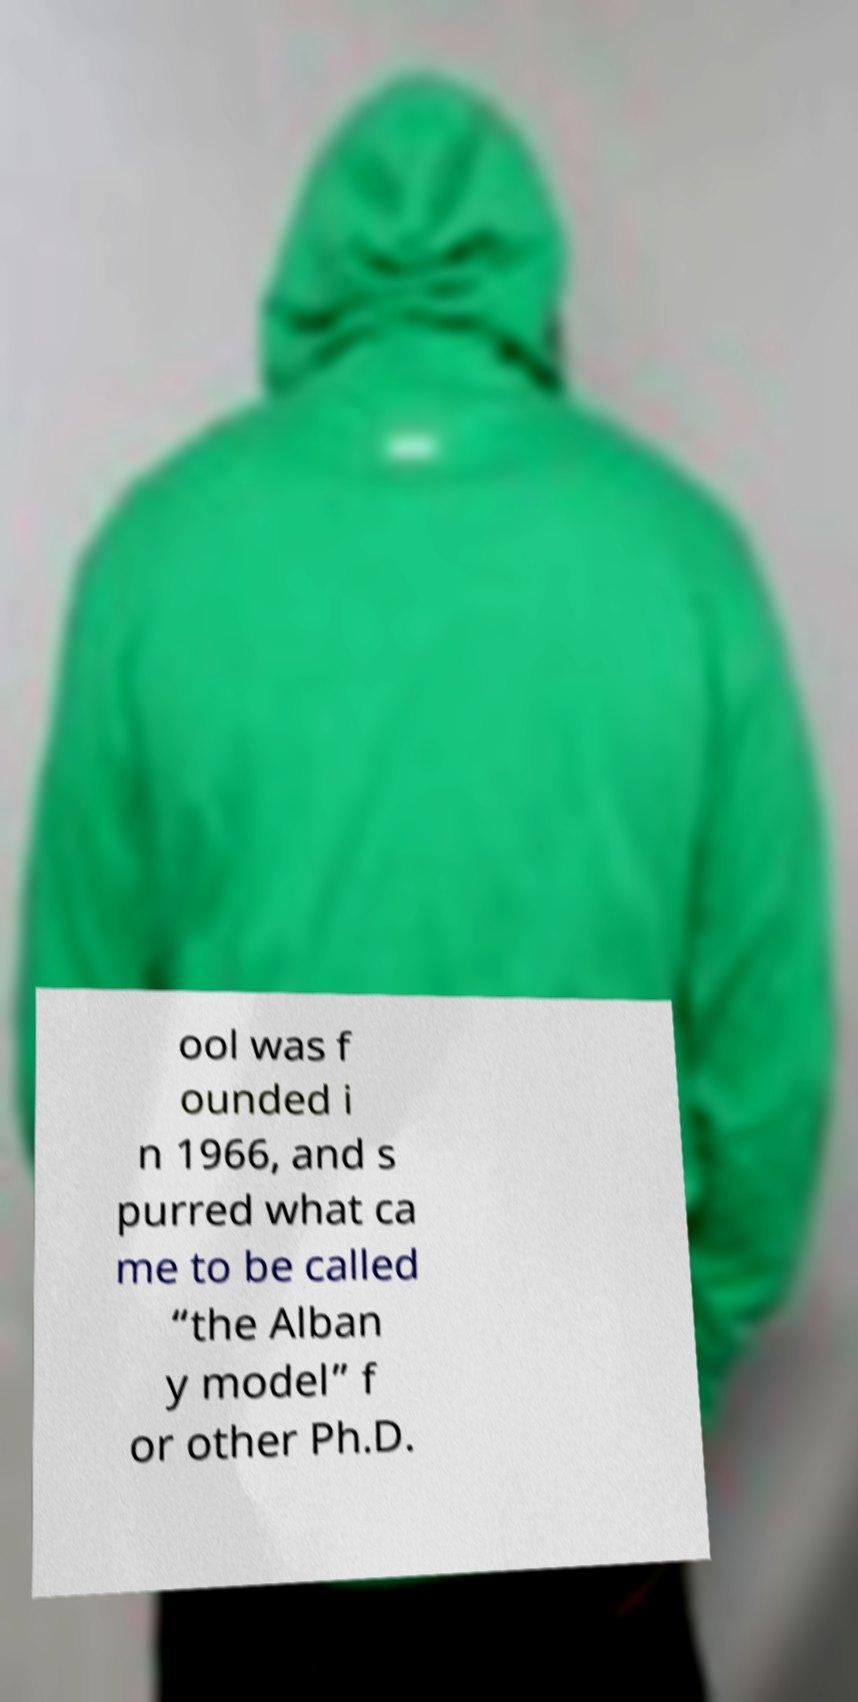Please read and relay the text visible in this image. What does it say? ool was f ounded i n 1966, and s purred what ca me to be called “the Alban y model” f or other Ph.D. 